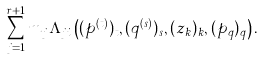<formula> <loc_0><loc_0><loc_500><loc_500>\sum _ { j = 1 } ^ { r + 1 } m _ { j } \Lambda _ { j i } \left ( ( p ^ { ( t ) } ) _ { t } , ( q ^ { ( s ) } ) _ { s } , ( z _ { k } ) _ { k } , ( p _ { q } ) _ { q } \right ) .</formula> 